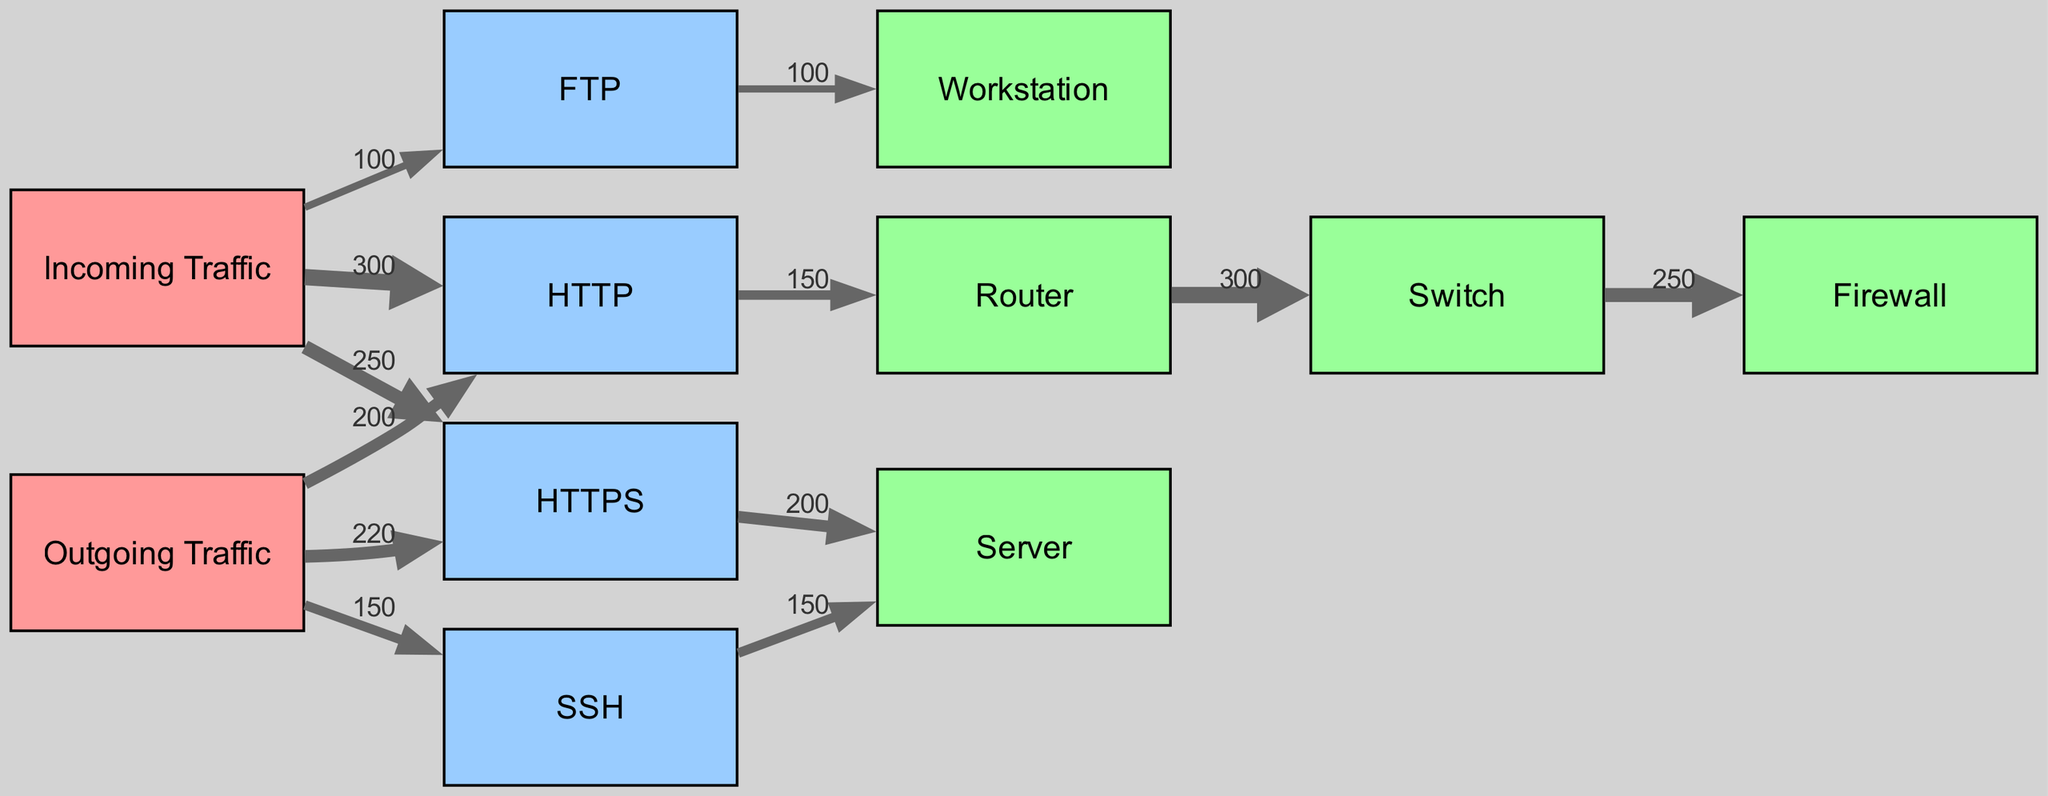What is the total incoming traffic? To find the total incoming traffic, we need to sum the values of all incoming traffic links. The values are 300 (HTTP), 250 (HTTPS), and 100 (FTP). Adding these together gives us 300 + 250 + 100 = 650.
Answer: 650 Which protocol has the highest outgoing traffic? We look at the outgoing traffic values: 200 (HTTP), 220 (HTTPS), and 150 (SSH). The highest value among these is 220, which corresponds to HTTPS.
Answer: HTTPS What is the value of the link between HTTP and Router? The link between HTTP and Router has a value of 150, as stated in the data.
Answer: 150 How many device types are displayed in the diagram? The device types listed in the diagram are Router, Switch, Firewall, Server, and Workstation. Counting these gives us a total of 5 device types.
Answer: 5 What is the total value of outgoing traffic directed to the Server? There are two outgoing traffic links directed to the Server: one from HTTPS (value 200) and one from SSH (value 150). To find the total, we sum these two values: 200 + 150 = 350.
Answer: 350 Which protocol is associated with the Workstation? According to the diagram, the protocol associated with the Workstation is FTP, which has a direct outgoing traffic link to it.
Answer: FTP What connects the Router to the Switch? The connection between the Router and the Switch is represented by a traffic link with a value of 300. This indicates that there is a flow of 300 units from the Router to the Switch.
Answer: 300 How much incoming traffic is allocated to FTP? The incoming traffic allocated to FTP is represented by a single value link of 100.
Answer: 100 Which device receives the most outgoing traffic? By examining the outgoing traffic links, we find that the highest outgoing traffic is directed to the Server (200 from HTTPS and 150 from SSH), totaling 350. Therefore, the device receiving the most outgoing traffic is the Server.
Answer: Server 